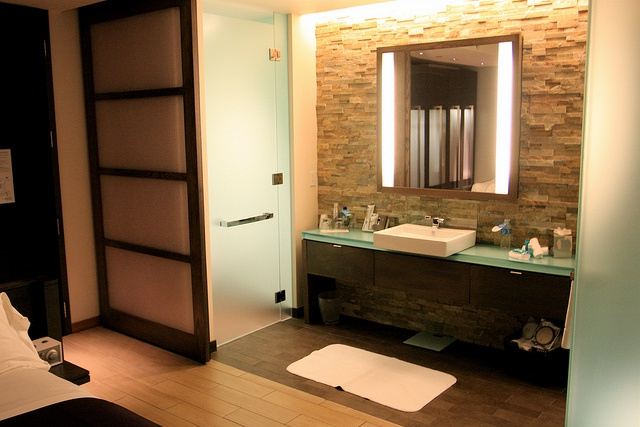Describe the objects in this image and their specific colors. I can see bed in maroon, black, and tan tones, sink in maroon and tan tones, bottle in maroon, olive, gray, and teal tones, bottle in maroon, darkgreen, gray, olive, and darkgray tones, and bottle in maroon, tan, and olive tones in this image. 